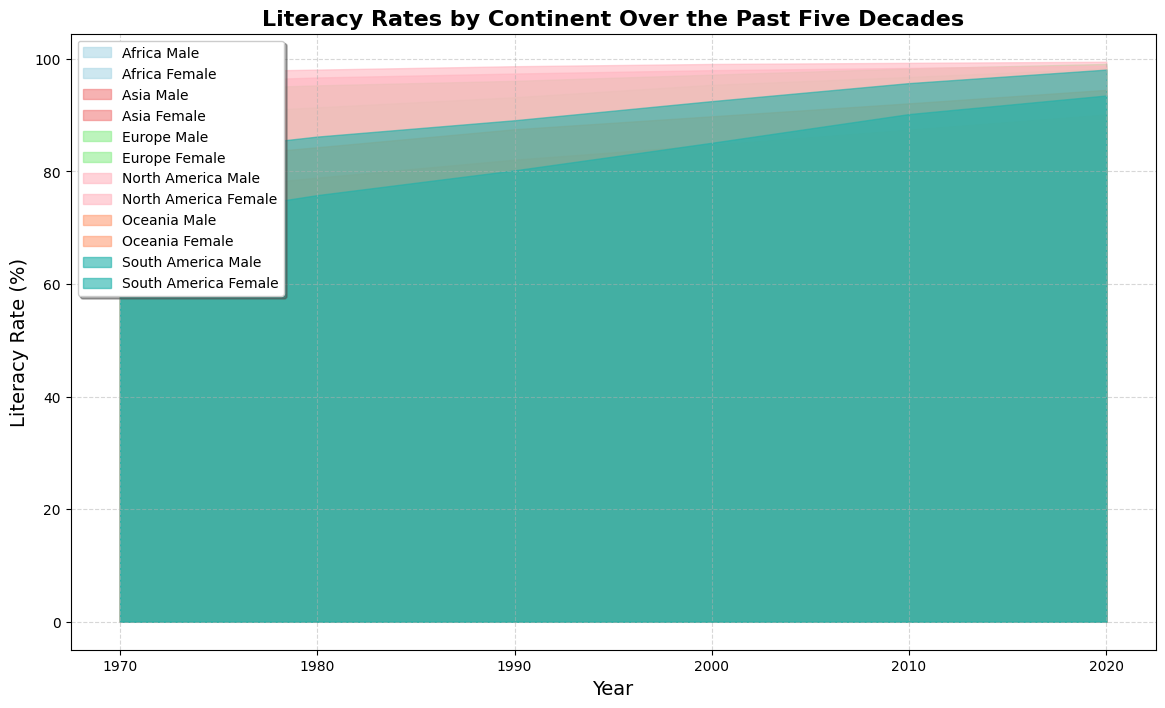What is the trend in literacy rates for males in Africa from 1970 to 2020? The chart shows an increasing trend for male literacy rates in Africa from 45.3% in 1970 to 75.3% in 2020.
Answer: Increasing Which continent had the highest female literacy rate in 2020? By viewing the chart, Europe shows the highest female literacy rate in 2020 with a rate just above 98%.
Answer: Europe How does the female literacy rate in Asia in 1970 compare with the male literacy rate in Oceania in the same year? The female literacy rate in Asia in 1970 is visually shown to be lower at around 35.2%, compared to the male literacy rate in Oceania which is higher at approximately 81.2%.
Answer: Lower What is the difference between male literacy rates in North America and South America in 2020? From the chart, the male literacy rate in North America in 2020 is about 99.5% and in South America, it is about 98.1%. The difference is 99.5% - 98.1% = 1.4%.
Answer: 1.4% Which gender had a smaller increase in literacy rates in Africa from 1970 to 2020? In 1970, male literacy rate in Africa is 45.3% and increased to 75.3% in 2020 (an increase of 30%). The female literacy rate in Africa is 23.4% in 1970 and increased to 61.8% in 2020 (an increase of 38.4%). Therefore, males had a smaller increase at 30%.
Answer: Male By how much did the literacy rate for females in South America increase from 1970 to 2020? From the chart, the female literacy rate in South America increased from 70.4% in 1970 to 93.5% in 2020. The increase is 93.5% - 70.4% = 23.1%.
Answer: 23.1% Compare the increase in literacy rates for females in Africa and Europe from 2000 to 2020. In Africa, the female literacy rate in 2000 was 48.0% and increased to 61.8% in 2020 (an increase of 13.8%). In Europe, the rate was 95.4% in 2000 and increased to 98.3% in 2020 (an increase of 2.9%). Africa had a higher increase.
Answer: Africa Which continent shows the least disparity between male and female literacy rates in 2020? The chart reveals that Europe has the least disparity between male (99.1%) and female (98.3%) literacy rates in 2020, showing a difference of only 0.8%.
Answer: Europe 